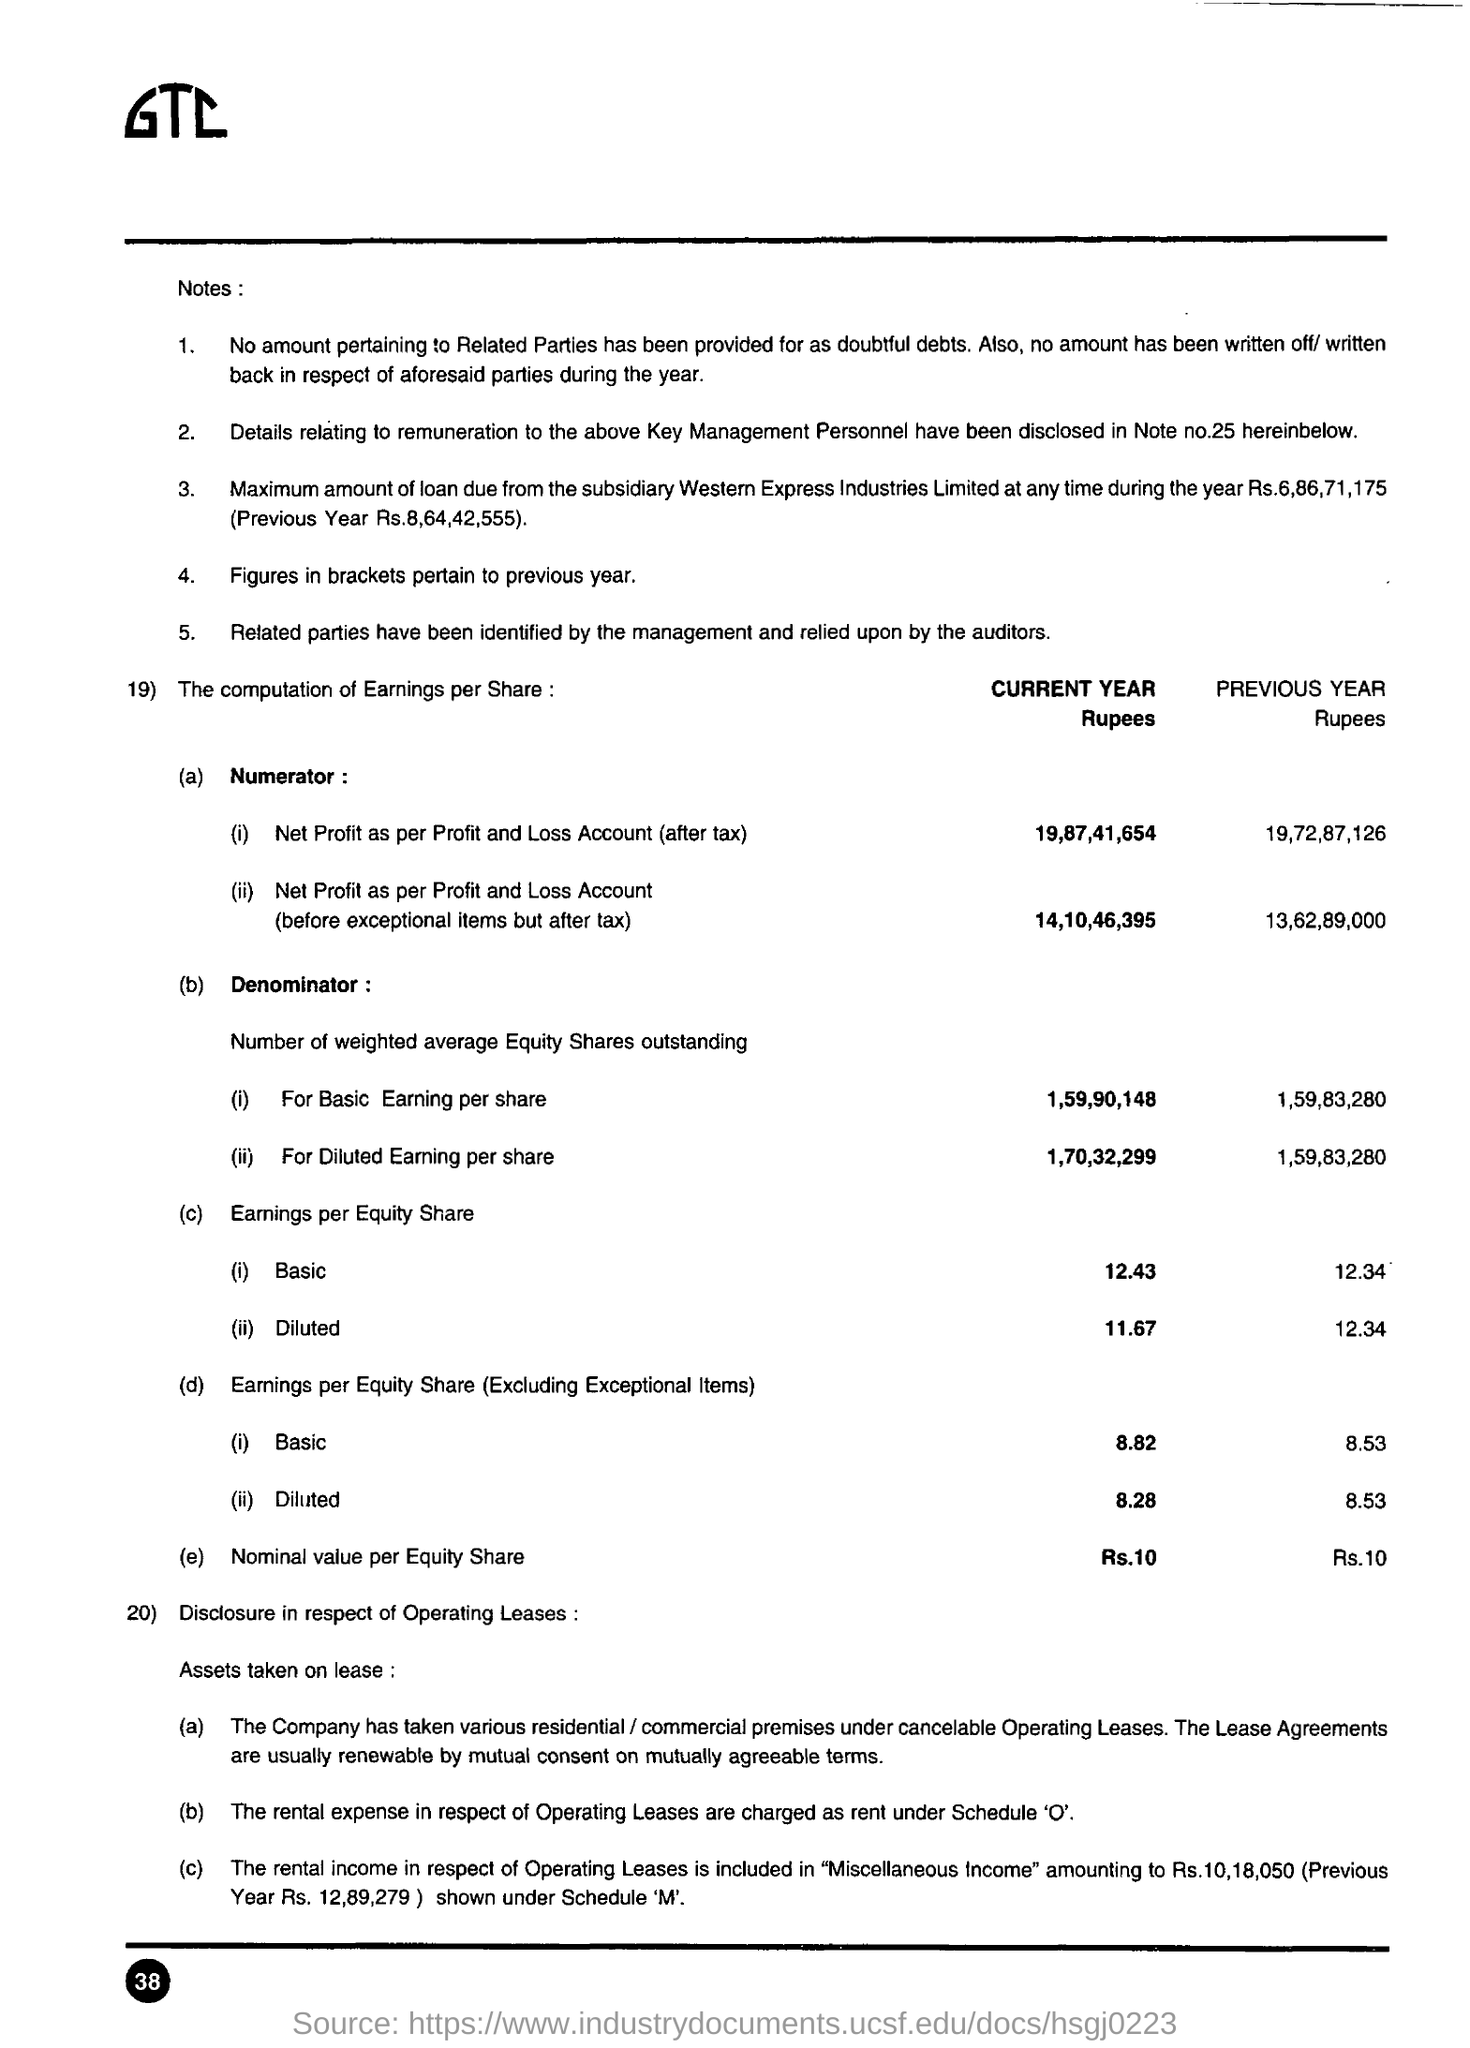How much is the net profit as per profit and loss account(after tax) for current year?
Provide a succinct answer. 19,87,41,654. How much is the nominal value per equity share for current year?
Make the answer very short. Rs.10. How are the lease agreements renewed?
Provide a succinct answer. By mutual consent on mutually agreeable terms. The rental income in respect of operating leases is uncluded in which income?
Offer a very short reply. Miscellaneous income. Which year does the figures in brackets pertain to?
Your answer should be very brief. Previous Year. How much is the previous year maximum amount of loan due from the subsidiary western express industries limited?
Offer a very short reply. Rs. 8,64,42,555. Where is the details relating to renumeration to key management personnel have been disclosed in?
Your answer should be very brief. Note no.25. 